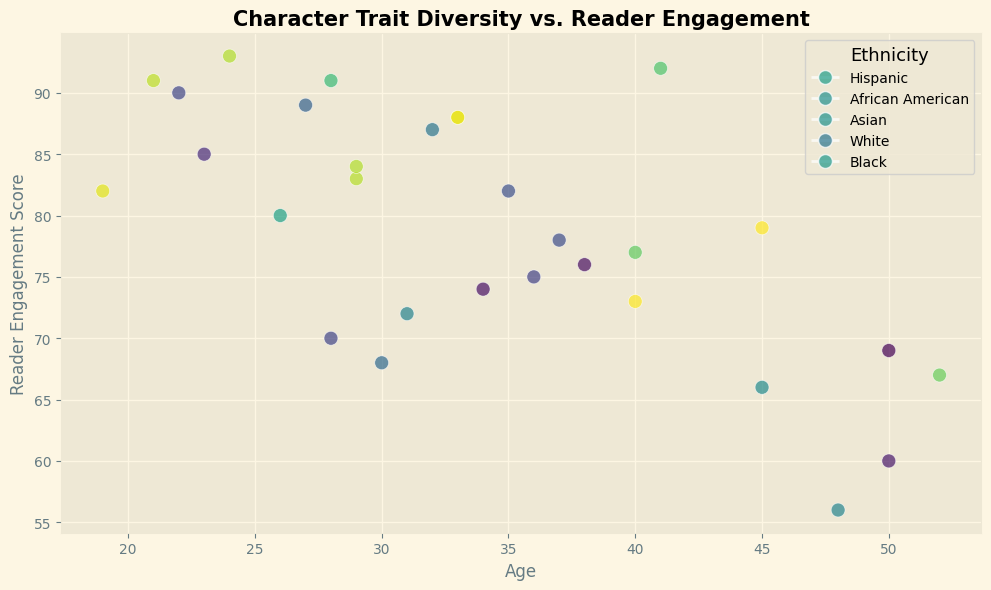What is the average age of characters with a Reader Engagement Score greater than 85? First, identify characters with a Reader Engagement Score greater than 85, which are characters 2, 6, 11, 14, 23, 20, 25, and 29. Their ages are 28, 27, 22, 41, 29, 24, 21, and 32 respectively. Sum these ages (28 + 27 + 22 + 41 + 29 + 24 + 21 + 32 = 224) and divide by the number of characters (8). The average age is 224/8 = 28
Answer: 28 How does the reader engagement for male characters compare to female characters? Identify the Reader Engagement Scores for male characters (82, 68, 60, 83, 88, 70, 84, 73, 56) and female characters (91, 77, 89, 90, 92, 72, 75, 87, 93, 66). Calculate the average for males (82 + 68 + 60 + 83 + 88 + 70 + 84 + 73 + 56 = 584, average = 584/9 = 64.89) and females (91 + 77 + 89 + 90 + 92 + 72 + 75 + 87 + 93 + 66 = 832, average = 832/10 = 83.2). Female characters have higher average engagement scores.
Answer: Female characters have higher engagement Which ethnicity group has the highest reader engagement score? Look at the scatter plot and compare the highest engagement scores for each ethnicity group: Hisp (91), AfricAmer (91), Asian (93), White (87), Black (80). The highest score is for an Asian character.
Answer: Asian Is there a notable trend between age and reader engagement score for non-binary characters? Observe the scatter plot for non-binary characters. Identify their ages and engagement scores: (23, 85), (45, 79), (38, 76), (19, 82), (37, 78), (24, 88), (50, 69). There is no clear trend; data points are scattered without indicating a positive or negative correlation.
Answer: No notable trend Which character has the lowest reader engagement score, and what is their age and ethnicity? Locate the point with the lowest Reader Engagement Score in the scatter plot. The lowest score is 56 for a character aged 48 who is Hispanic.
Answer: Character aged 48, Hispanic 